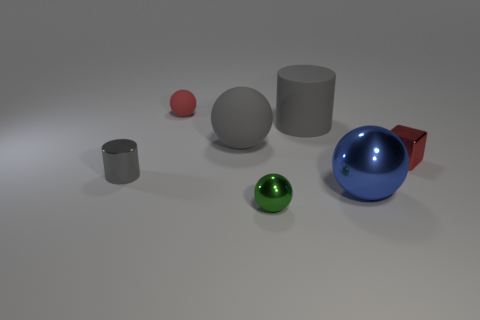Are there any spheres of the same color as the shiny cylinder?
Give a very brief answer. Yes. There is a gray thing that is on the right side of the green object; does it have the same size as the tiny matte object?
Offer a terse response. No. The tiny cylinder is what color?
Provide a short and direct response. Gray. There is a thing on the left side of the red thing that is to the left of the big blue metal ball; what color is it?
Provide a succinct answer. Gray. Is there another small red sphere made of the same material as the red ball?
Your answer should be compact. No. What material is the cylinder that is on the left side of the large gray object left of the green object?
Your answer should be compact. Metal. What number of large gray matte things have the same shape as the green thing?
Your response must be concise. 1. The blue metal object is what shape?
Your response must be concise. Sphere. Is the number of red metallic spheres less than the number of tiny metal spheres?
Your answer should be very brief. Yes. Is there anything else that is the same size as the red ball?
Make the answer very short. Yes. 